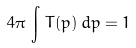<formula> <loc_0><loc_0><loc_500><loc_500>4 \pi \, \int \, T ( p ) \, d p = 1</formula> 